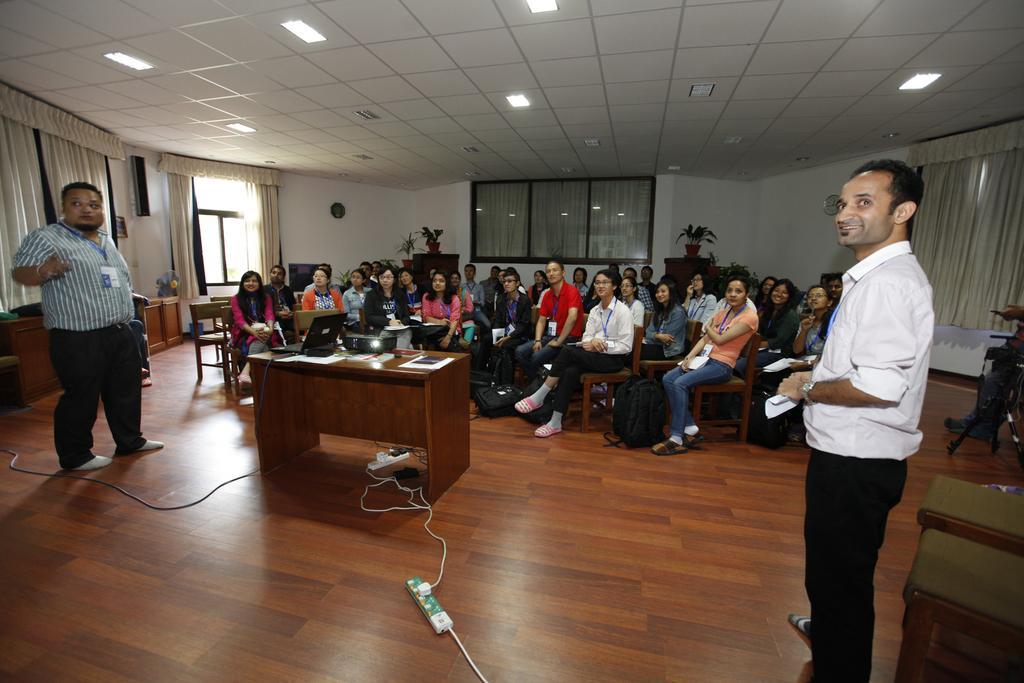Please provide a concise description of this image. In this image I can see 2 people standing in a room. There is a projector and a laptop on a table. People are sitting on the chairs and there are plants, windows, curtains and door at the back. There are lights at the top. There are wires in the front. 